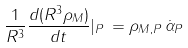<formula> <loc_0><loc_0><loc_500><loc_500>\frac { 1 } { R ^ { 3 } } \frac { d ( R ^ { 3 } { \rho } _ { M } ) } { d t } | _ { P } \, = { \rho } _ { M , P } \, \dot { \alpha } _ { P }</formula> 